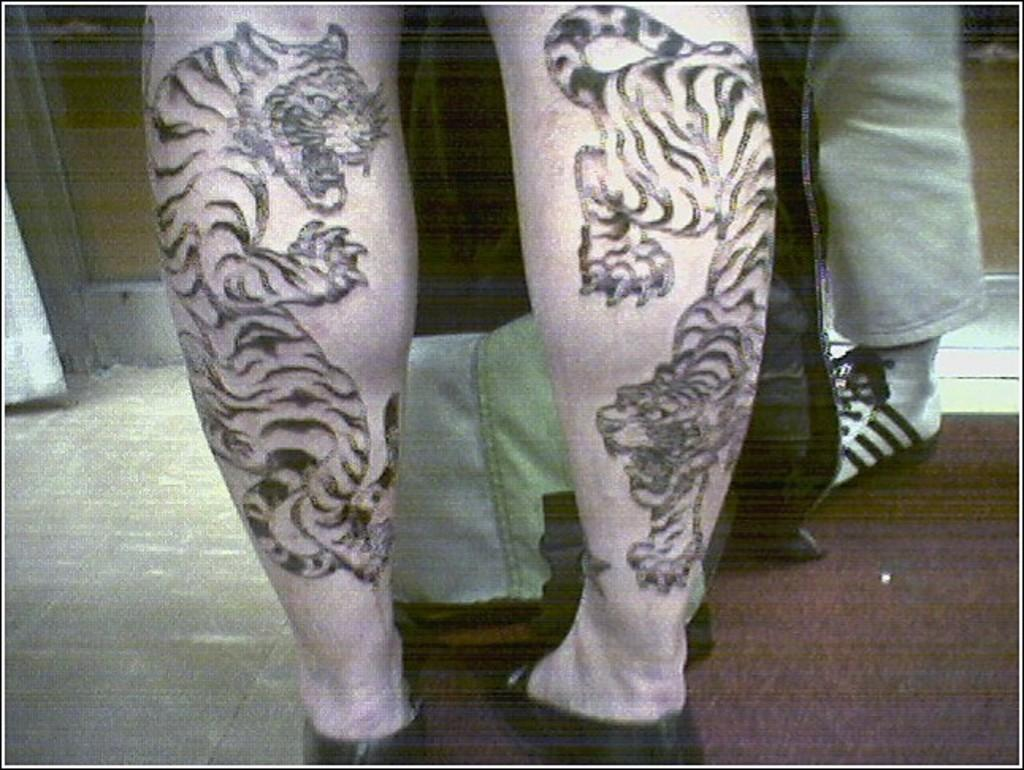What is visible on the legs of the person in the image? There are tattoos on the legs of a person in the image. What is located in front of the person with tattoos? There is an object in front of the person with tattoos. Are there any other legs visible in the image? Yes, there are legs of another person visible in the image. What is the surface that the legs are standing on? There is a floor at the bottom of the image. What type of rail can be seen on the person's chin in the image? There is no rail present on the person's chin in the image. What type of flag is visible in the image? There is no flag visible in the image. 